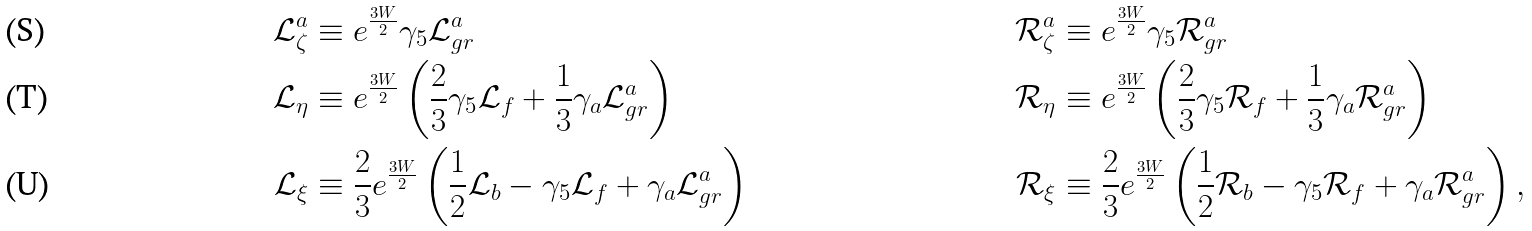<formula> <loc_0><loc_0><loc_500><loc_500>\mathcal { L } _ { \zeta } ^ { a } & \equiv e ^ { \frac { 3 W } { 2 } } \gamma _ { 5 } \mathcal { L } _ { g r } ^ { a } & \mathcal { R } _ { \zeta } ^ { a } & \equiv e ^ { \frac { 3 W } { 2 } } \gamma _ { 5 } \mathcal { R } _ { g r } ^ { a } \\ \mathcal { L } _ { \eta } & \equiv e ^ { \frac { 3 W } { 2 } } \left ( \frac { 2 } { 3 } \gamma _ { 5 } \mathcal { L } _ { f } + \frac { 1 } { 3 } \gamma _ { a } \mathcal { L } ^ { a } _ { g r } \right ) & \mathcal { R } _ { \eta } & \equiv e ^ { \frac { 3 W } { 2 } } \left ( \frac { 2 } { 3 } \gamma _ { 5 } \mathcal { R } _ { f } + \frac { 1 } { 3 } \gamma _ { a } \mathcal { R } _ { g r } ^ { a } \right ) \\ \mathcal { L } _ { \xi } & \equiv \frac { 2 } { 3 } e ^ { \frac { 3 W } { 2 } } \left ( \frac { 1 } { 2 } \mathcal { L } _ { b } - \gamma _ { 5 } \mathcal { L } _ { f } + \gamma _ { a } \mathcal { L } ^ { a } _ { g r } \right ) & \mathcal { R } _ { \xi } & \equiv \frac { 2 } { 3 } e ^ { \frac { 3 W } { 2 } } \left ( \frac { 1 } { 2 } \mathcal { R } _ { b } - \gamma _ { 5 } \mathcal { R } _ { f } + \gamma _ { a } \mathcal { R } _ { g r } ^ { a } \right ) ,</formula> 